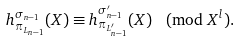<formula> <loc_0><loc_0><loc_500><loc_500>h _ { \pi _ { L _ { n - 1 } } } ^ { \sigma _ { n - 1 } } ( X ) \equiv h _ { \pi _ { L _ { n - 1 } ^ { \prime } } } ^ { \sigma _ { n - 1 } ^ { \prime } } ( X ) \pmod { X ^ { l } } .</formula> 